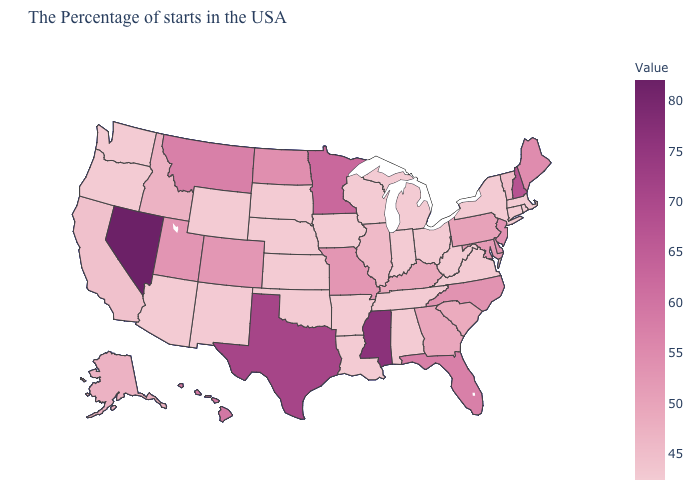Does Nevada have the highest value in the USA?
Quick response, please. Yes. Does the map have missing data?
Answer briefly. No. Among the states that border Massachusetts , which have the lowest value?
Be succinct. Rhode Island, Connecticut, New York. Among the states that border Tennessee , which have the highest value?
Give a very brief answer. Mississippi. Does Mississippi have the highest value in the South?
Concise answer only. Yes. 